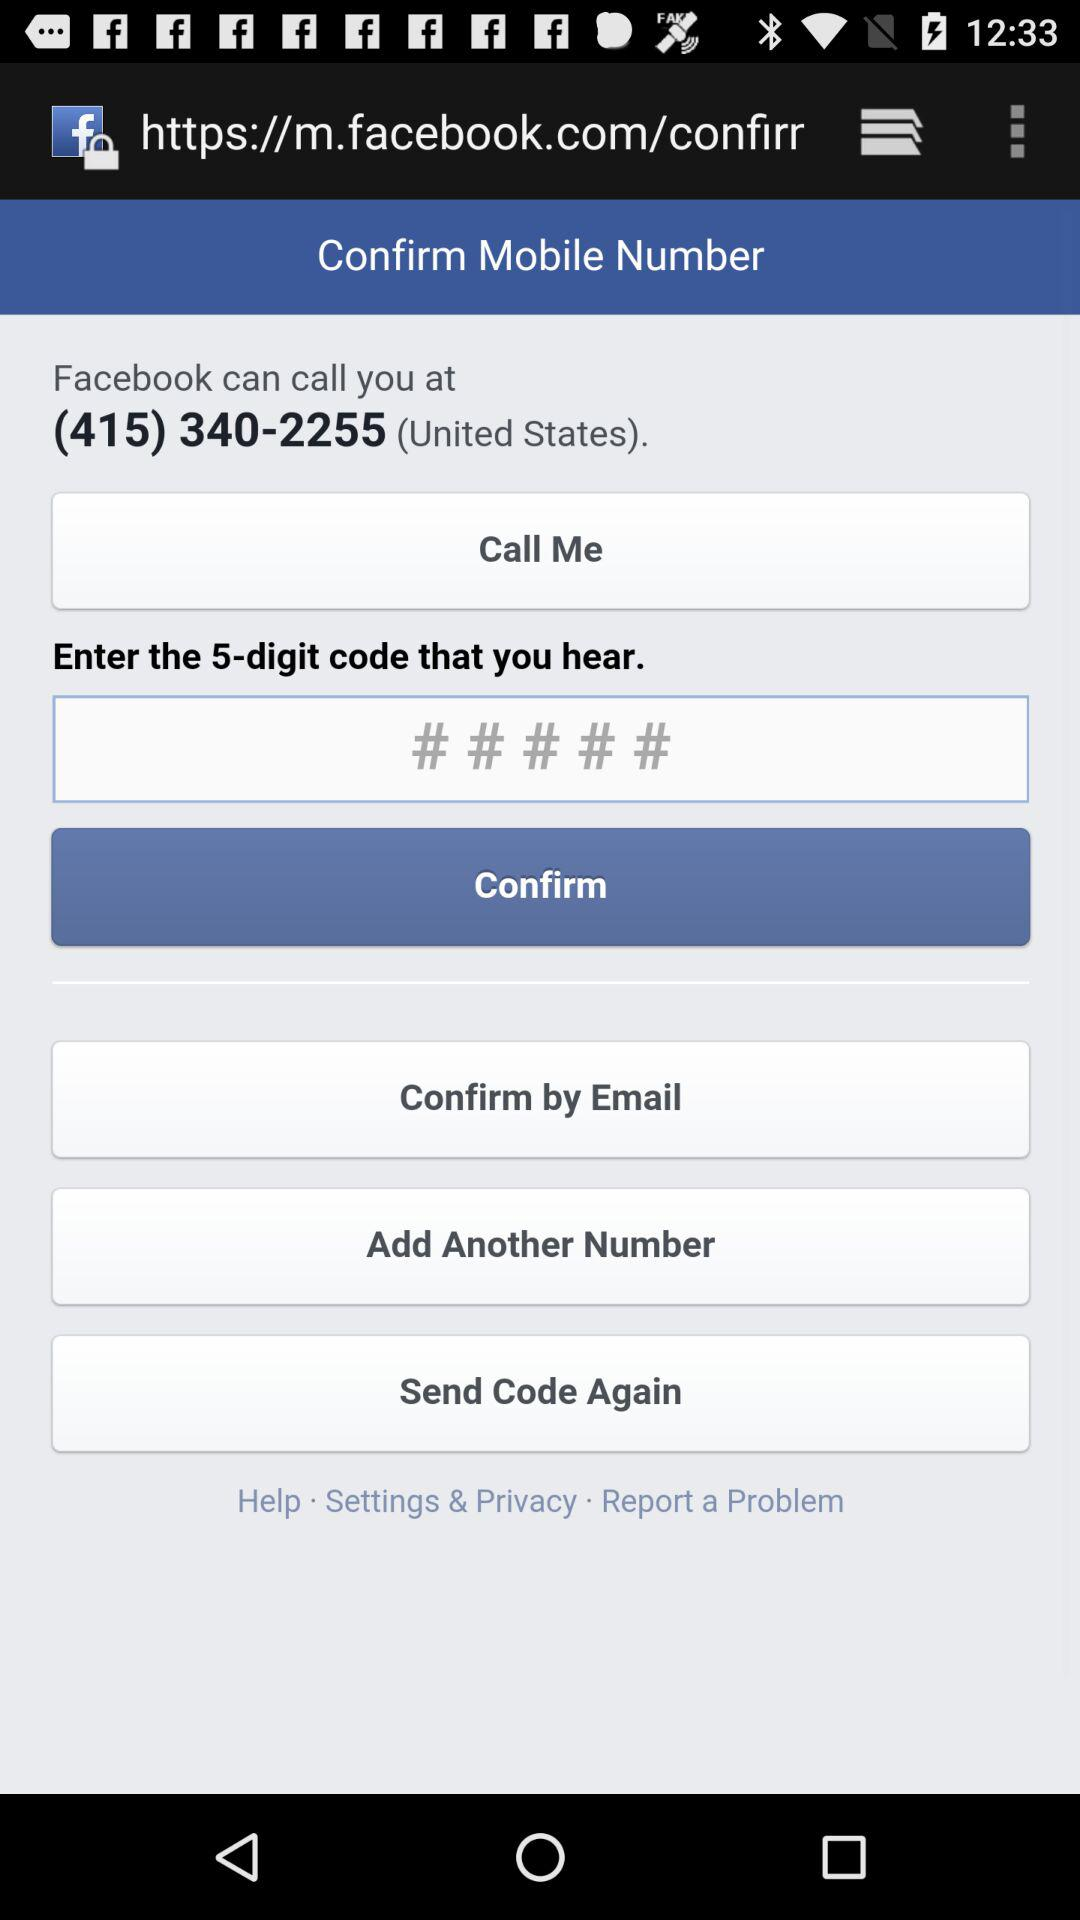Which country is selected?
When the provided information is insufficient, respond with <no answer>. <no answer> 